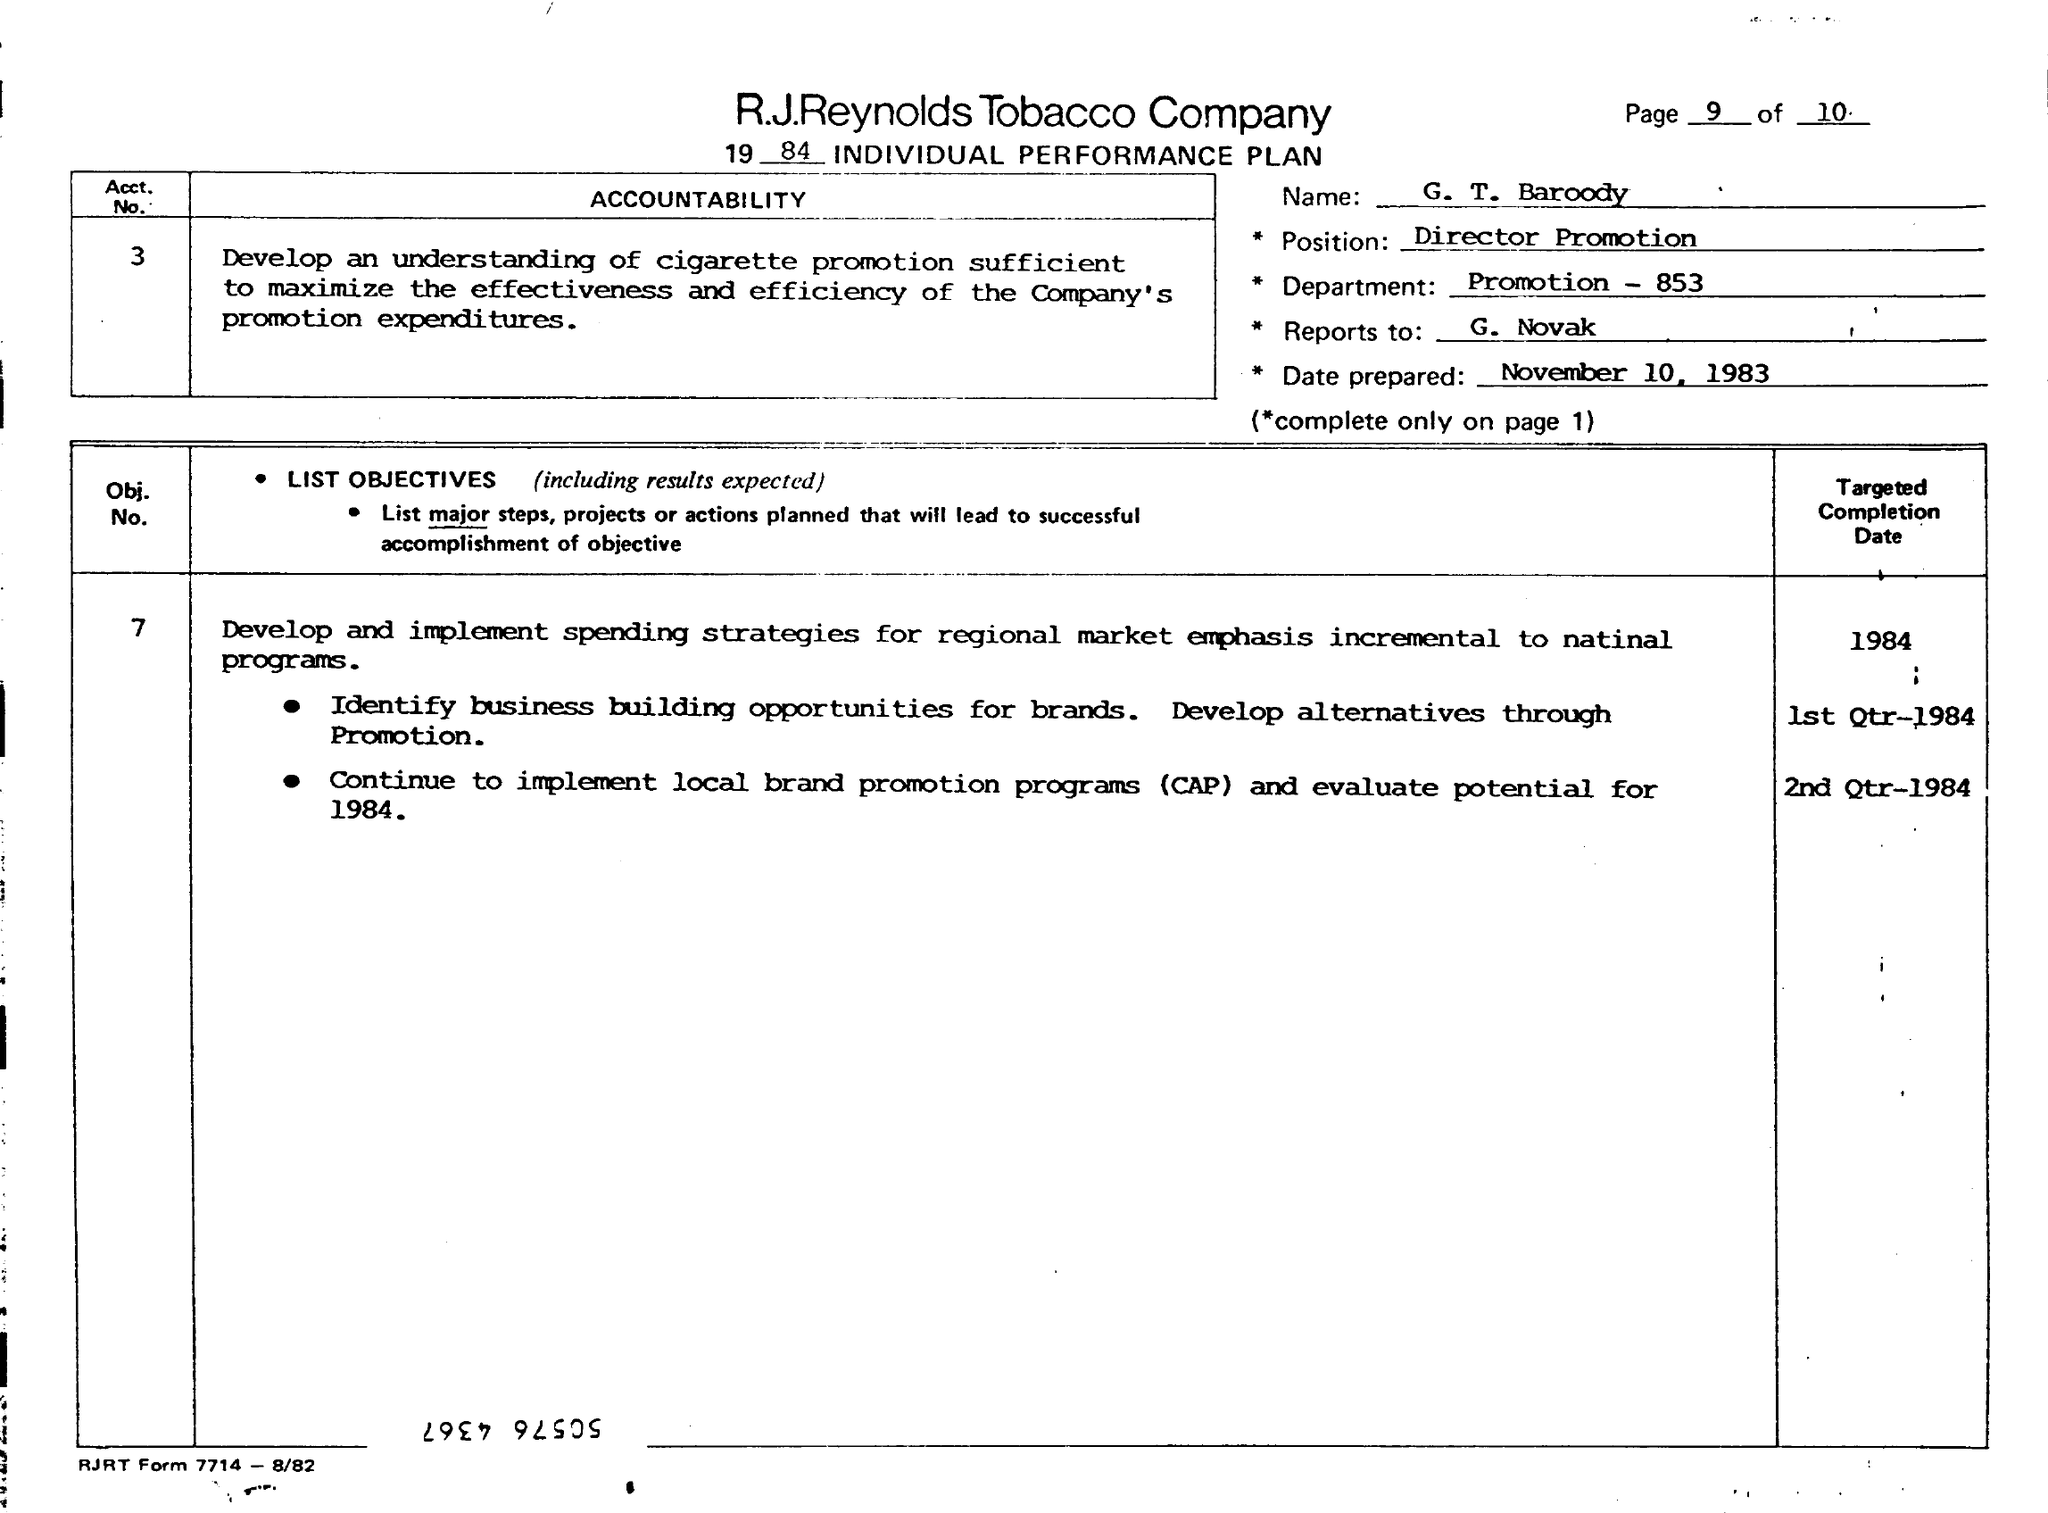Indicate a few pertinent items in this graphic. The position mentioned in the plan is Director Promotion. The R.J. Reynolds Tobacco Company is the name of a company. This plan is prepared on November 10, 1983. The name of the individual whose performance is mentioned in the plan is G.T. Baroody. 